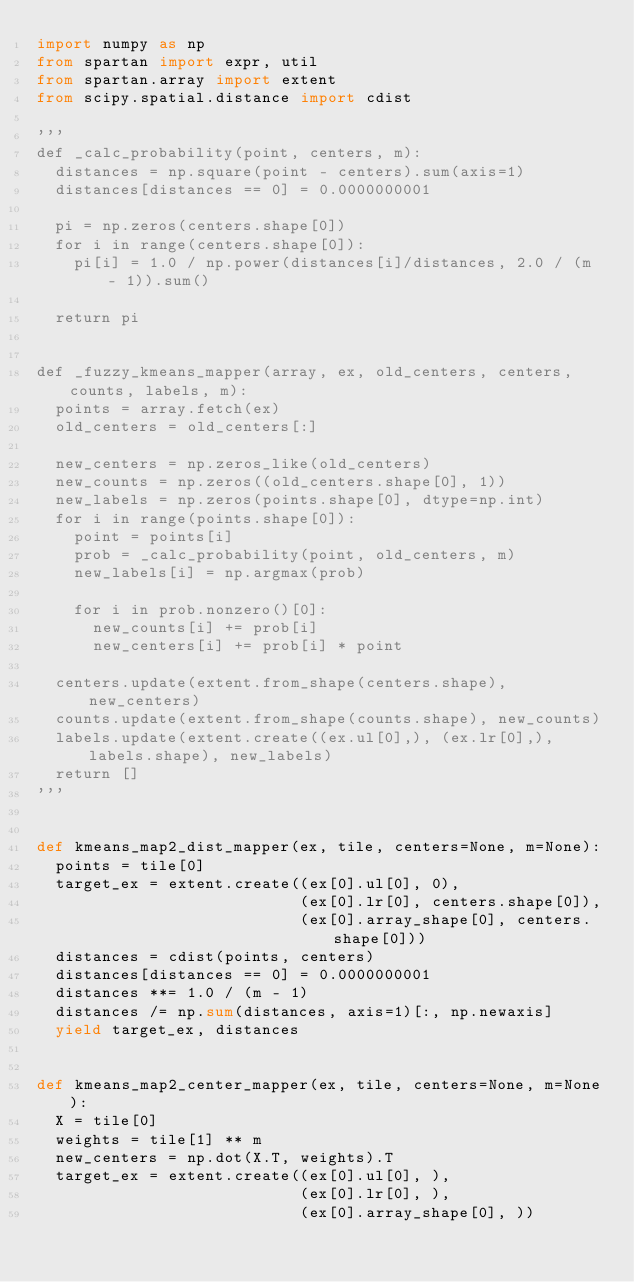Convert code to text. <code><loc_0><loc_0><loc_500><loc_500><_Python_>import numpy as np
from spartan import expr, util
from spartan.array import extent
from scipy.spatial.distance import cdist

'''
def _calc_probability(point, centers, m):
  distances = np.square(point - centers).sum(axis=1)
  distances[distances == 0] = 0.0000000001

  pi = np.zeros(centers.shape[0])
  for i in range(centers.shape[0]):
    pi[i] = 1.0 / np.power(distances[i]/distances, 2.0 / (m - 1)).sum()

  return pi


def _fuzzy_kmeans_mapper(array, ex, old_centers, centers, counts, labels, m):
  points = array.fetch(ex)
  old_centers = old_centers[:]

  new_centers = np.zeros_like(old_centers)
  new_counts = np.zeros((old_centers.shape[0], 1))
  new_labels = np.zeros(points.shape[0], dtype=np.int)
  for i in range(points.shape[0]):
    point = points[i]
    prob = _calc_probability(point, old_centers, m)
    new_labels[i] = np.argmax(prob)

    for i in prob.nonzero()[0]:
      new_counts[i] += prob[i]
      new_centers[i] += prob[i] * point

  centers.update(extent.from_shape(centers.shape), new_centers)
  counts.update(extent.from_shape(counts.shape), new_counts)
  labels.update(extent.create((ex.ul[0],), (ex.lr[0],), labels.shape), new_labels)
  return []
'''


def kmeans_map2_dist_mapper(ex, tile, centers=None, m=None):
  points = tile[0]
  target_ex = extent.create((ex[0].ul[0], 0),
                            (ex[0].lr[0], centers.shape[0]),
                            (ex[0].array_shape[0], centers.shape[0]))
  distances = cdist(points, centers)
  distances[distances == 0] = 0.0000000001
  distances **= 1.0 / (m - 1)
  distances /= np.sum(distances, axis=1)[:, np.newaxis]
  yield target_ex, distances


def kmeans_map2_center_mapper(ex, tile, centers=None, m=None):
  X = tile[0]
  weights = tile[1] ** m
  new_centers = np.dot(X.T, weights).T
  target_ex = extent.create((ex[0].ul[0], ),
                            (ex[0].lr[0], ),
                            (ex[0].array_shape[0], ))</code> 